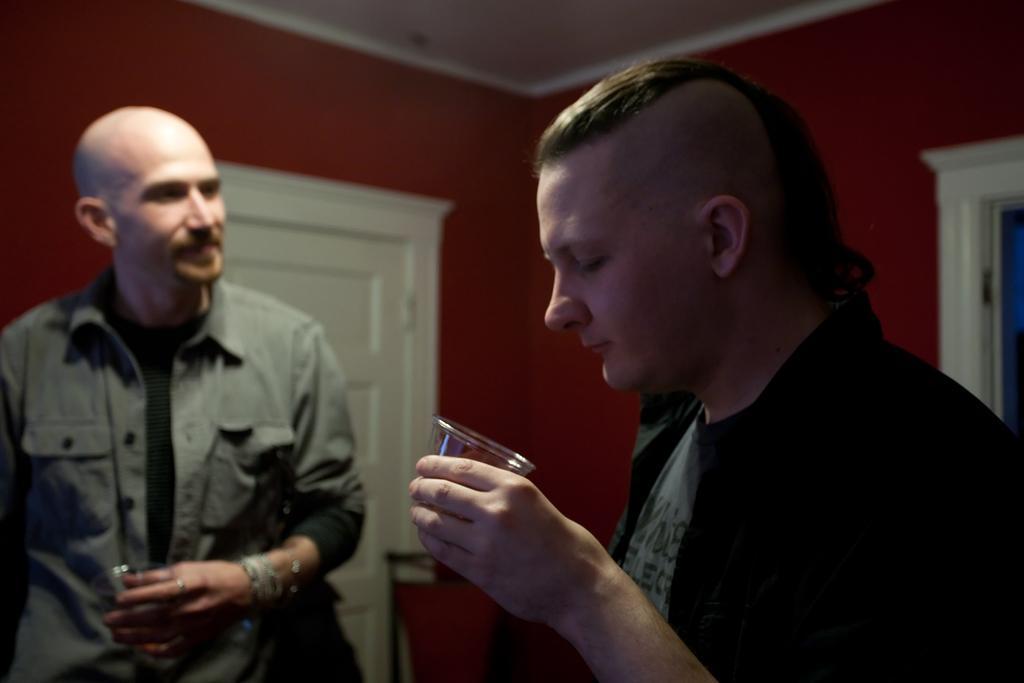Can you describe this image briefly? As we can see in the image there are two persons standing in the front. The man on the left side is wearing grey color jacket. The man on the right side is wearing black color jacket and holding glass. There is a red color wall and door. 